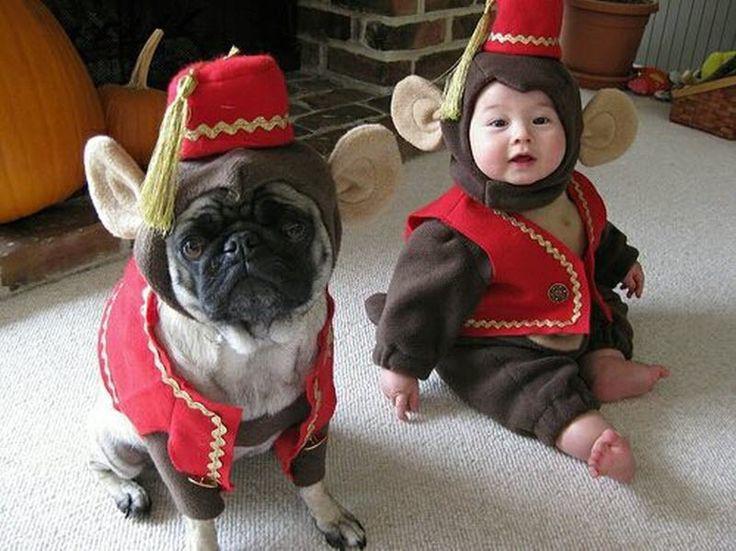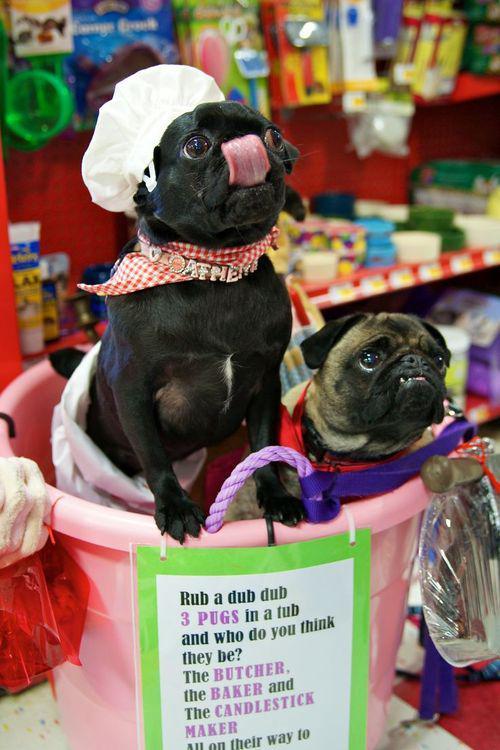The first image is the image on the left, the second image is the image on the right. Examine the images to the left and right. Is the description "An image shows two costumed pug dogs inside a container." accurate? Answer yes or no. Yes. The first image is the image on the left, the second image is the image on the right. Assess this claim about the two images: "In one image, there are two pugs in a container that has a paper on it with printed text.". Correct or not? Answer yes or no. Yes. 